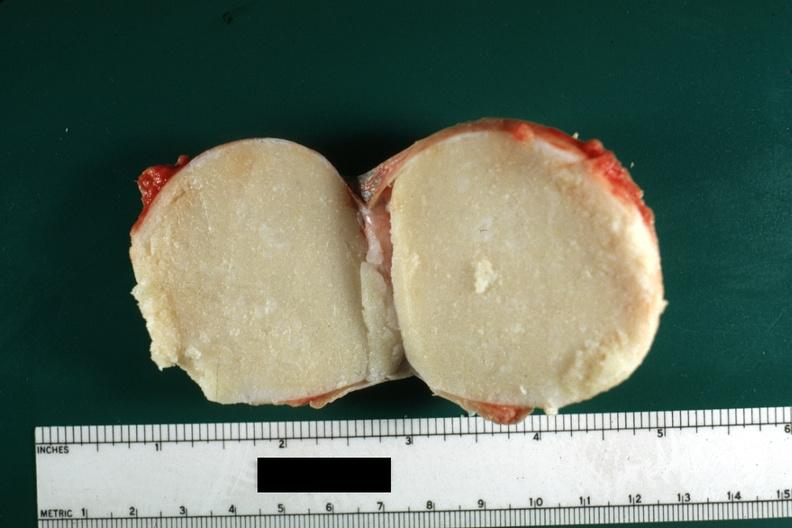does this image show cut surface typical cheese like yellow content and thin fibrous capsule this lesion was from the scrotal skin?
Answer the question using a single word or phrase. Yes 